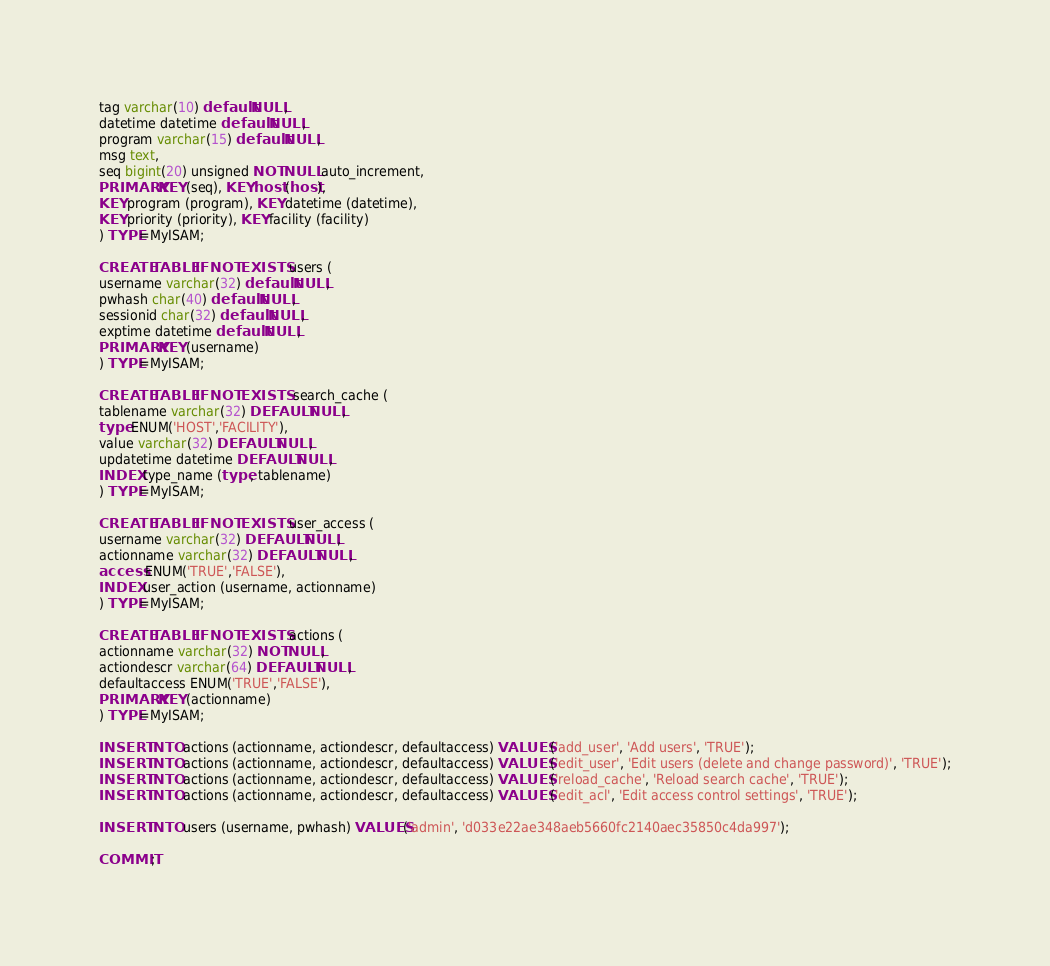<code> <loc_0><loc_0><loc_500><loc_500><_SQL_>tag varchar(10) default NULL,
datetime datetime default NULL,
program varchar(15) default NULL,
msg text,
seq bigint(20) unsigned NOT NULL auto_increment,
PRIMARY KEY (seq), KEY host (host),
KEY program (program), KEY datetime (datetime),
KEY priority (priority), KEY facility (facility)
) TYPE=MyISAM;

CREATE TABLE IF NOT EXISTS users (
username varchar(32) default NULL,
pwhash char(40) default NULL,
sessionid char(32) default NULL,
exptime datetime default NULL,
PRIMARY KEY (username)
) TYPE=MyISAM;

CREATE TABLE IF NOT EXISTS  search_cache (
tablename varchar(32) DEFAULT NULL,
type ENUM('HOST','FACILITY'),
value varchar(32) DEFAULT NULL,
updatetime datetime DEFAULT NULL,
INDEX type_name (type, tablename)
) TYPE=MyISAM;

CREATE TABLE IF NOT EXISTS user_access (
username varchar(32) DEFAULT NULL,
actionname varchar(32) DEFAULT NULL,
access ENUM('TRUE','FALSE'),
INDEX user_action (username, actionname)
) TYPE=MyISAM;

CREATE TABLE IF NOT EXISTS actions (
actionname varchar(32) NOT NULL,
actiondescr varchar(64) DEFAULT NULL,
defaultaccess ENUM('TRUE','FALSE'),
PRIMARY KEY (actionname)
) TYPE=MyISAM;

INSERT INTO actions (actionname, actiondescr, defaultaccess) VALUES ('add_user', 'Add users', 'TRUE');
INSERT INTO actions (actionname, actiondescr, defaultaccess) VALUES ('edit_user', 'Edit users (delete and change password)', 'TRUE');
INSERT INTO actions (actionname, actiondescr, defaultaccess) VALUES ('reload_cache', 'Reload search cache', 'TRUE');
INSERT INTO actions (actionname, actiondescr, defaultaccess) VALUES ('edit_acl', 'Edit access control settings', 'TRUE');

INSERT INTO users (username, pwhash) VALUES('admin', 'd033e22ae348aeb5660fc2140aec35850c4da997');

COMMIT;
</code> 